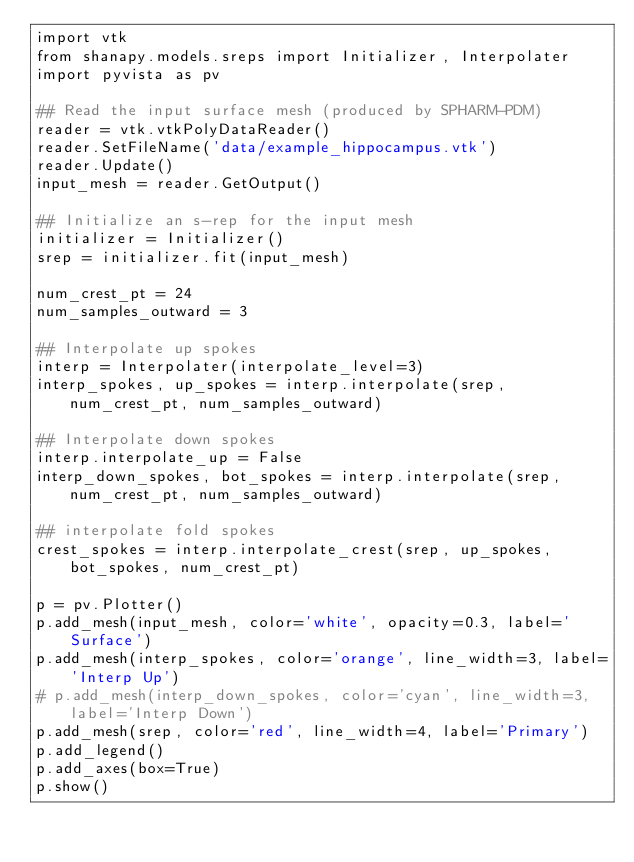<code> <loc_0><loc_0><loc_500><loc_500><_Python_>import vtk
from shanapy.models.sreps import Initializer, Interpolater
import pyvista as pv

## Read the input surface mesh (produced by SPHARM-PDM)
reader = vtk.vtkPolyDataReader()
reader.SetFileName('data/example_hippocampus.vtk')
reader.Update()
input_mesh = reader.GetOutput()

## Initialize an s-rep for the input mesh
initializer = Initializer()
srep = initializer.fit(input_mesh)

num_crest_pt = 24
num_samples_outward = 3

## Interpolate up spokes
interp = Interpolater(interpolate_level=3)
interp_spokes, up_spokes = interp.interpolate(srep, num_crest_pt, num_samples_outward)

## Interpolate down spokes
interp.interpolate_up = False
interp_down_spokes, bot_spokes = interp.interpolate(srep, num_crest_pt, num_samples_outward)

## interpolate fold spokes
crest_spokes = interp.interpolate_crest(srep, up_spokes, bot_spokes, num_crest_pt)

p = pv.Plotter()
p.add_mesh(input_mesh, color='white', opacity=0.3, label='Surface')
p.add_mesh(interp_spokes, color='orange', line_width=3, label='Interp Up')
# p.add_mesh(interp_down_spokes, color='cyan', line_width=3, label='Interp Down')
p.add_mesh(srep, color='red', line_width=4, label='Primary')
p.add_legend()
p.add_axes(box=True)
p.show()</code> 